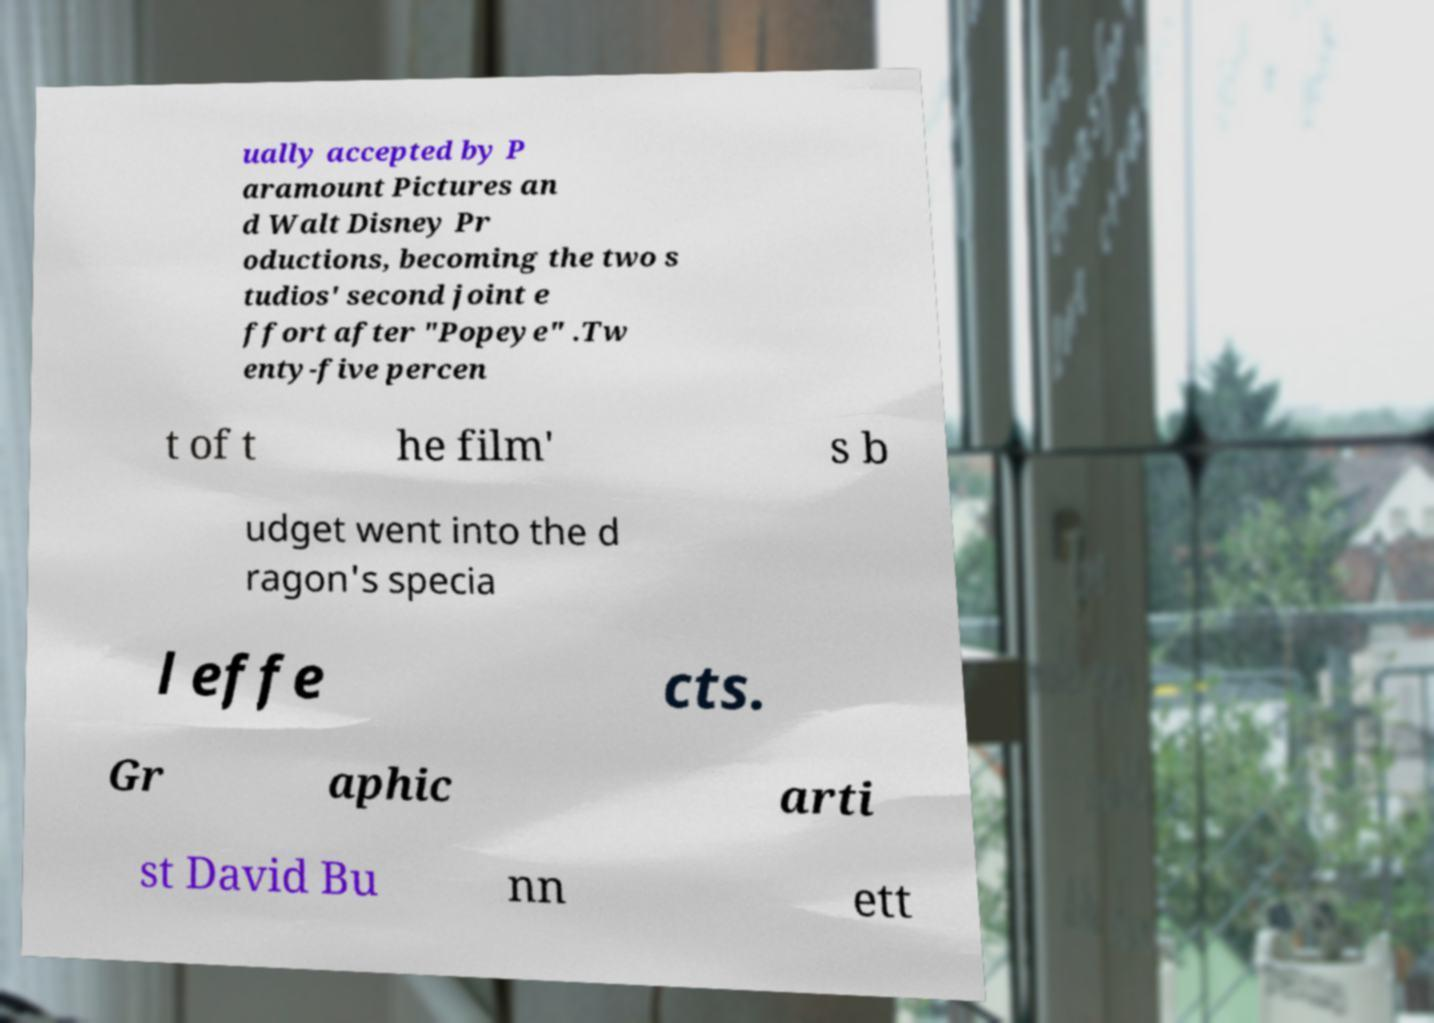What messages or text are displayed in this image? I need them in a readable, typed format. ually accepted by P aramount Pictures an d Walt Disney Pr oductions, becoming the two s tudios' second joint e ffort after "Popeye" .Tw enty-five percen t of t he film' s b udget went into the d ragon's specia l effe cts. Gr aphic arti st David Bu nn ett 